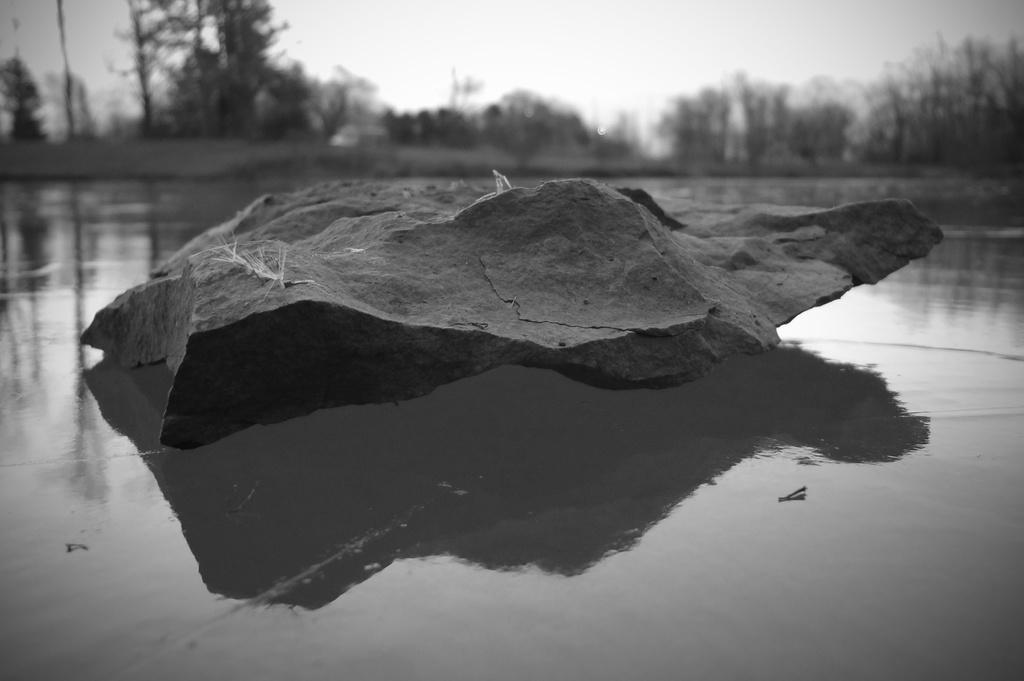Could you give a brief overview of what you see in this image? This is a black and white image where we can see a rock. In the background, we can see trees. At the top of the image, we can see the sky. It seems like water on the land at the bottom of the image. 